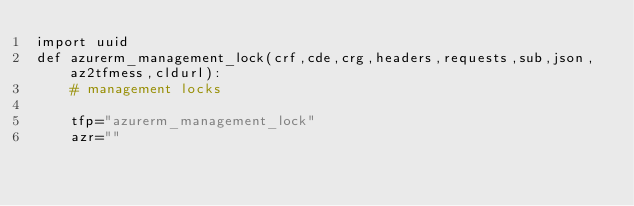<code> <loc_0><loc_0><loc_500><loc_500><_Python_>import uuid
def azurerm_management_lock(crf,cde,crg,headers,requests,sub,json,az2tfmess,cldurl):
    # management locks
    
    tfp="azurerm_management_lock"
    azr=""</code> 